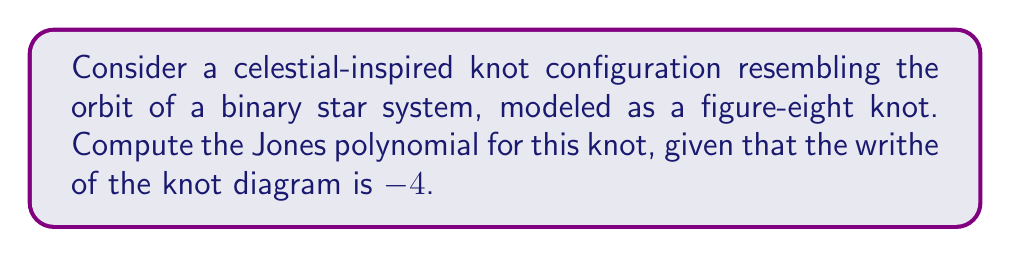Can you solve this math problem? To compute the Jones polynomial for the figure-eight knot, we'll follow these steps:

1. Recall the skein relation for the Jones polynomial:
   $$t^{-1}V(L_+) - tV(L_-) = (t^{1/2} - t^{-1/2})V(L_0)$$

2. For the figure-eight knot, we can use the following skein tree:
   [asy]
   import geometry;

   void drawCrossing(pair center, real size, bool positive) {
     draw(center + size*dir(45) -- center - size*dir(45), linewidth(0.8));
     if (positive) {
       draw(center + size*dir(135) -- center - size*dir(135), linewidth(0.8));
     } else {
       draw((center + size*dir(135)) - (0,0.1*size) -- (center - size*dir(135)) + (0,0.1*size), linewidth(0.8));
     }
   }

   pair c = (0,0);
   real s = 1;

   drawCrossing(c, s, true);
   label("$L_+$", c + (1.5*s,0));

   drawCrossing(c - (0,2*s), s, false);
   label("$L_-$", c + (1.5*s,-2*s));

   draw(c - (3*s,s) -- c - (2*s,s), linewidth(0.8));
   draw(c - (3*s,s) -- c - (3*s,s-0.5*s), linewidth(0.8));
   draw(c - (2*s,s) -- c - (2*s,s-0.5*s), linewidth(0.8));
   label("$L_0$", c + (-3.5*s,s));
   [/asy]

3. Apply the skein relation to each crossing, starting with the unknot (whose Jones polynomial is 1) as the base case.

4. For the figure-eight knot, we get the following equation:
   $$V(4_1) = -t^4 + t^3 + t - 1 + t^{-1}$$

5. To account for the writhe of -4, we need to multiply the polynomial by $(-t^{3/2})^{-4} = t^{-6}$:
   $$V(4_1) = t^{-6}(-t^4 + t^3 + t - 1 + t^{-1})$$

6. Simplify the expression:
   $$V(4_1) = -t^{-2} + t^{-3} + t^{-5} - t^{-6} + t^{-7}$$
Answer: $V(4_1) = -t^{-2} + t^{-3} + t^{-5} - t^{-6} + t^{-7}$ 